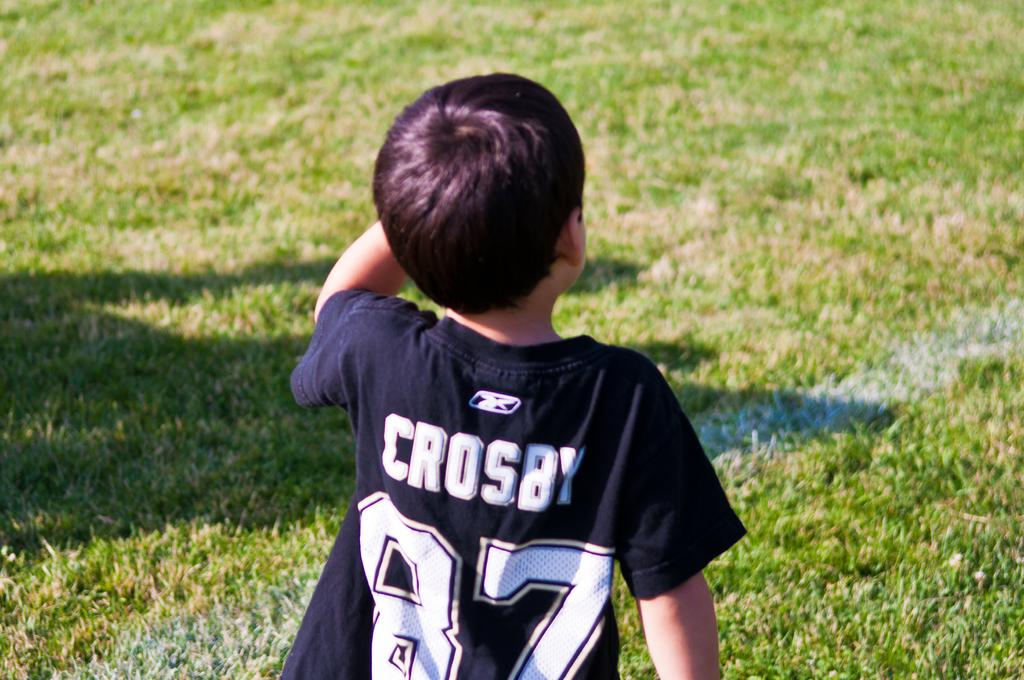<image>
Write a terse but informative summary of the picture. Boy wearing a shirt that says Crosby on it. 